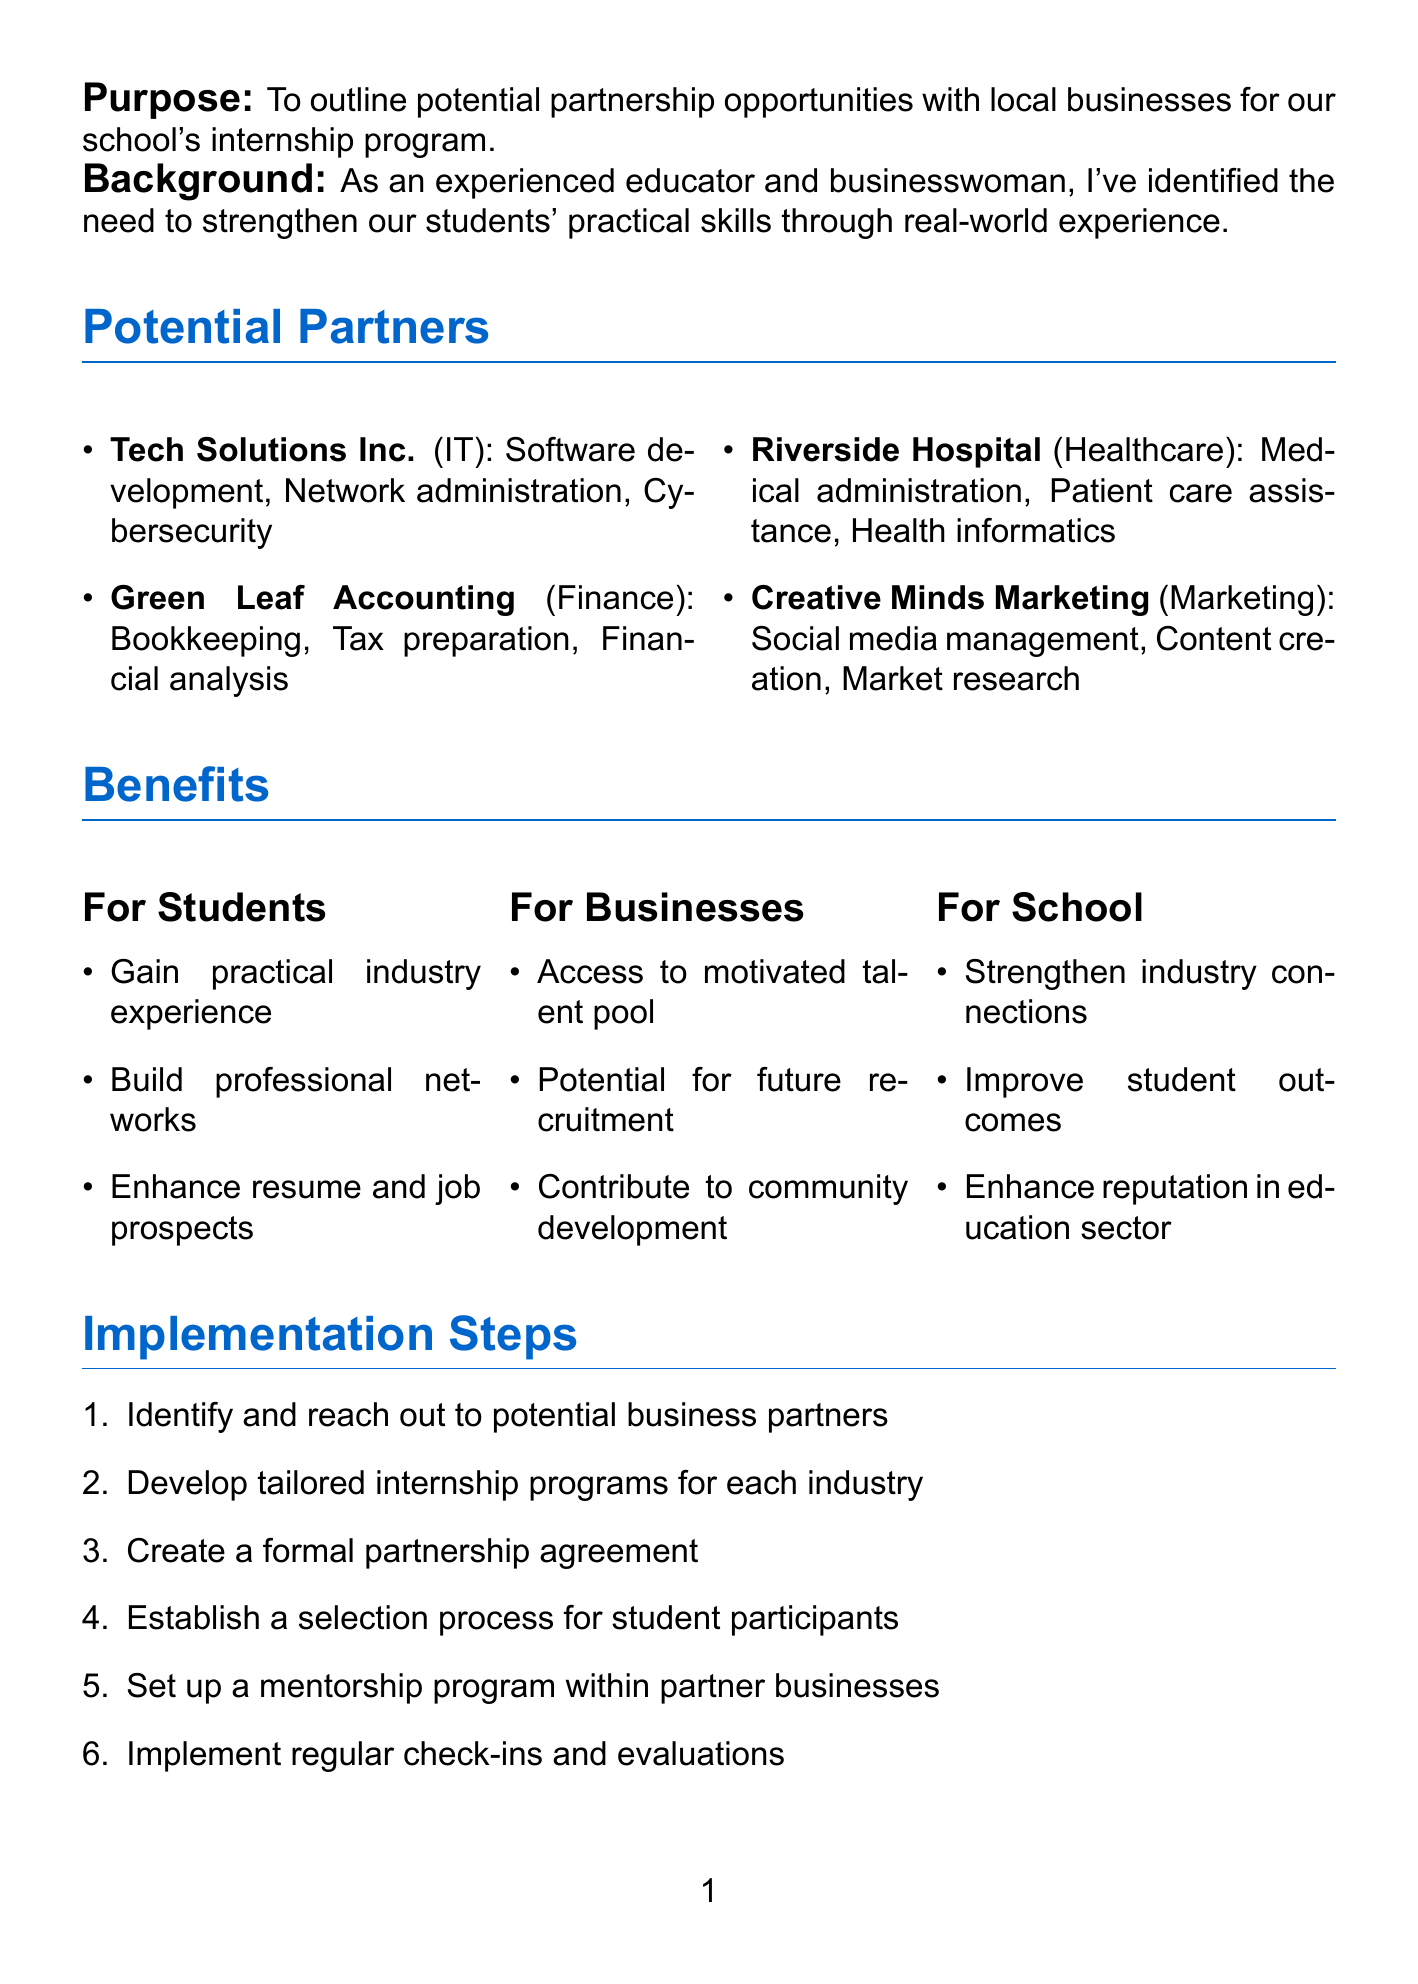What is the title of the memo? The title of the memo is stated at the beginning, indicating its focus on partnership opportunities.
Answer: Partnership Opportunities with Local Businesses for Internship Programs How many potential partners are listed? The number of potential partners is counted in the "Potential Partners" section of the document.
Answer: 4 What is one opportunity provided by Tech Solutions Inc.? The document lists opportunities for each potential partner, including at least one for Tech Solutions Inc.
Answer: Software development What is the benefit for students? The benefits for students are enumerated, providing a clear understanding of what they gain from the internship program.
Answer: Gain practical industry experience What is the planning phase duration? The duration for the planning phase is specified in the "Timeline" section, indicating how long it will take to plan the program.
Answer: 2 months What is one implementation step mentioned? One of the proposed steps for implementing the program is detailed in the "Implementation Steps" section.
Answer: Identify and reach out to potential business partners What are the success metrics? The "Success Metrics" section outlines various measurements for evaluating the internship program's effectiveness.
Answer: Number of successful placements What is the next step after discussing the initiative? The "Next Steps" section provides guidance on proceeding after the discussion of the initiative.
Answer: Schedule a meeting with the board 